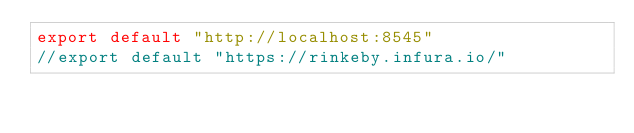Convert code to text. <code><loc_0><loc_0><loc_500><loc_500><_JavaScript_>export default "http://localhost:8545"
//export default "https://rinkeby.infura.io/"
</code> 